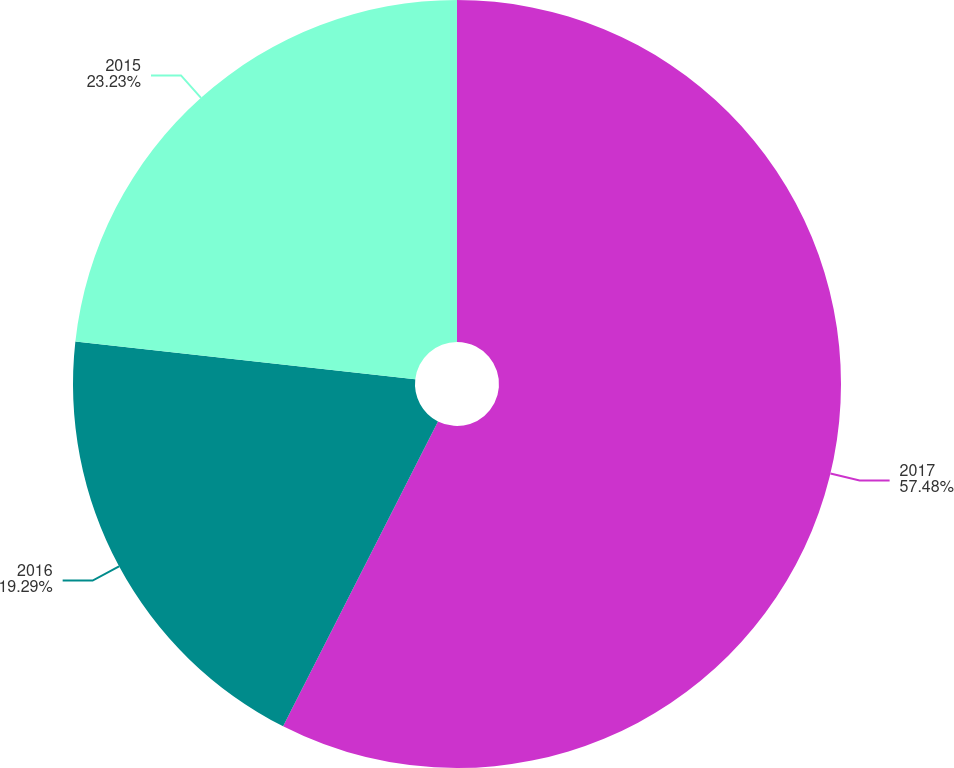<chart> <loc_0><loc_0><loc_500><loc_500><pie_chart><fcel>2017<fcel>2016<fcel>2015<nl><fcel>57.48%<fcel>19.29%<fcel>23.23%<nl></chart> 